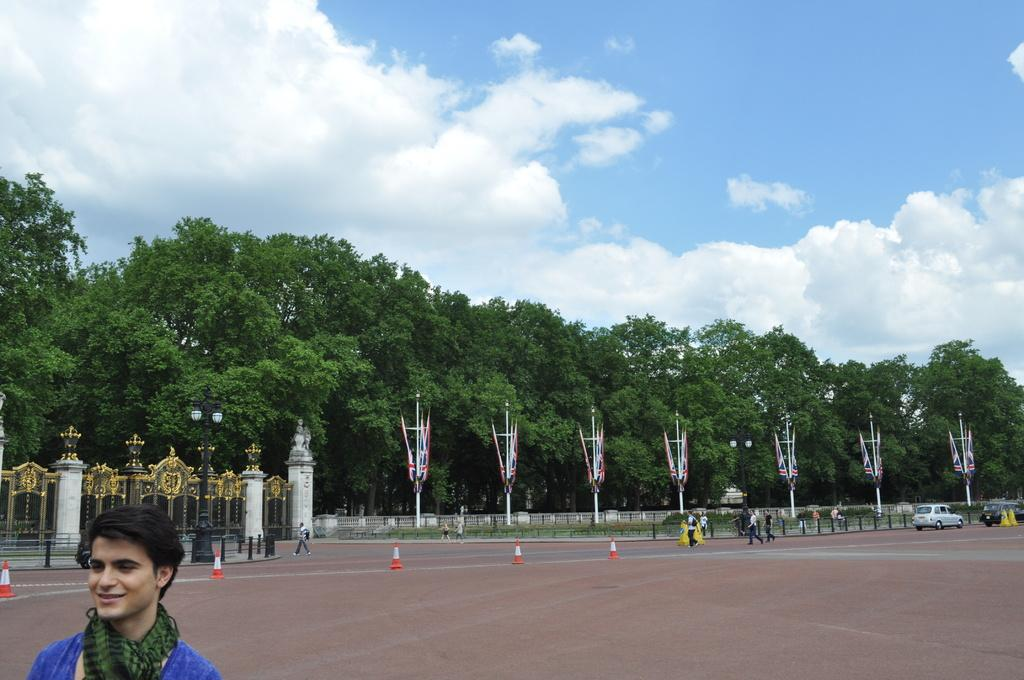What type of natural elements can be seen in the image? There are trees in the image. Can you describe the people in the image? There are people in the image. What type of temporary barriers are present in the image? Traffic cones are present in the image. What type of barrier is present in the image that is more permanent? There is a fence in the image. What type of vertical structures are present in the image? There are poles in the image. What type of man-made object is visible in the image? A vehicle is visible in the image. What other objects can be seen on the ground in the image? Other objects are present on the ground. What can be seen in the background of the image? The sky is visible in the background of the image. What type of joke is being told by the trees in the image? There are no jokes being told by the trees in the image, as trees are inanimate objects and cannot speak or tell jokes. What new idea is being proposed by the poles in the image? There are no new ideas being proposed by the poles in the image, as poles are inanimate objects and cannot propose ideas. 